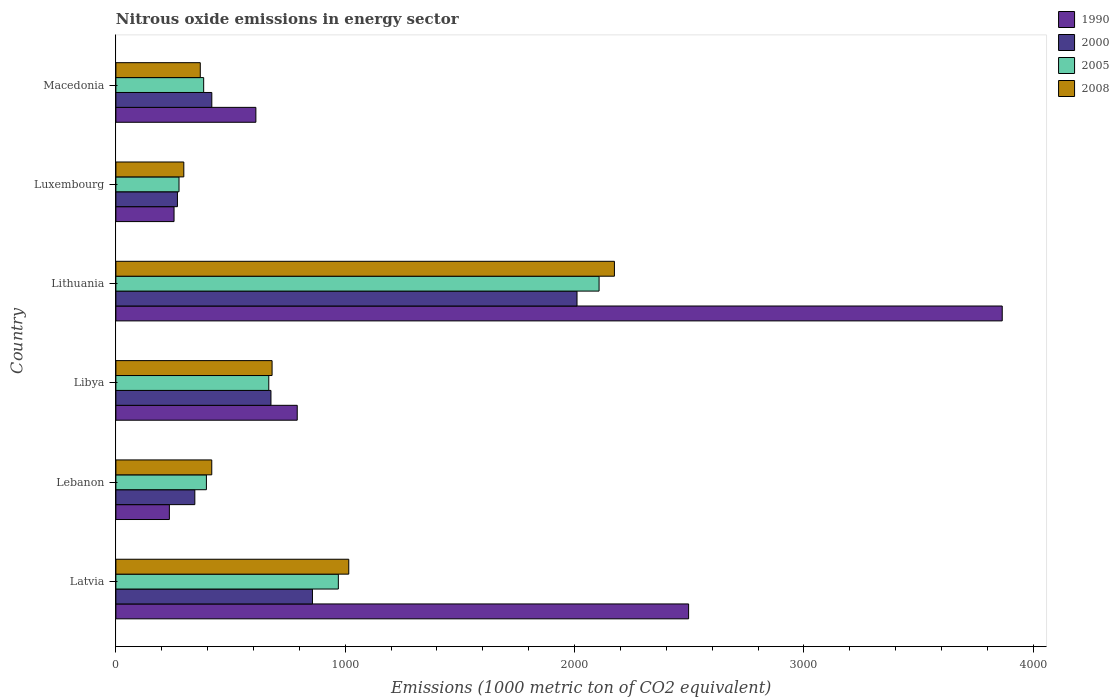How many different coloured bars are there?
Keep it short and to the point. 4. Are the number of bars on each tick of the Y-axis equal?
Ensure brevity in your answer.  Yes. How many bars are there on the 3rd tick from the bottom?
Your answer should be compact. 4. What is the label of the 1st group of bars from the top?
Make the answer very short. Macedonia. What is the amount of nitrous oxide emitted in 2005 in Libya?
Your response must be concise. 666.7. Across all countries, what is the maximum amount of nitrous oxide emitted in 2000?
Provide a succinct answer. 2010.8. Across all countries, what is the minimum amount of nitrous oxide emitted in 2008?
Your answer should be compact. 296.2. In which country was the amount of nitrous oxide emitted in 2008 maximum?
Your response must be concise. Lithuania. In which country was the amount of nitrous oxide emitted in 2005 minimum?
Give a very brief answer. Luxembourg. What is the total amount of nitrous oxide emitted in 1990 in the graph?
Give a very brief answer. 8250.4. What is the difference between the amount of nitrous oxide emitted in 2000 in Latvia and that in Luxembourg?
Give a very brief answer. 588.7. What is the difference between the amount of nitrous oxide emitted in 2000 in Libya and the amount of nitrous oxide emitted in 1990 in Lithuania?
Offer a very short reply. -3188.8. What is the average amount of nitrous oxide emitted in 2005 per country?
Offer a very short reply. 799.42. What is the difference between the amount of nitrous oxide emitted in 2005 and amount of nitrous oxide emitted in 2000 in Lithuania?
Make the answer very short. 96.2. In how many countries, is the amount of nitrous oxide emitted in 2008 greater than 1600 1000 metric ton?
Your answer should be compact. 1. What is the ratio of the amount of nitrous oxide emitted in 2008 in Latvia to that in Lithuania?
Make the answer very short. 0.47. Is the amount of nitrous oxide emitted in 1990 in Lebanon less than that in Lithuania?
Give a very brief answer. Yes. Is the difference between the amount of nitrous oxide emitted in 2005 in Lithuania and Luxembourg greater than the difference between the amount of nitrous oxide emitted in 2000 in Lithuania and Luxembourg?
Your answer should be compact. Yes. What is the difference between the highest and the second highest amount of nitrous oxide emitted in 1990?
Make the answer very short. 1367.6. What is the difference between the highest and the lowest amount of nitrous oxide emitted in 2008?
Make the answer very short. 1877.7. Is the sum of the amount of nitrous oxide emitted in 2008 in Latvia and Lebanon greater than the maximum amount of nitrous oxide emitted in 2005 across all countries?
Ensure brevity in your answer.  No. What does the 4th bar from the bottom in Lebanon represents?
Offer a very short reply. 2008. How many countries are there in the graph?
Provide a succinct answer. 6. What is the difference between two consecutive major ticks on the X-axis?
Offer a very short reply. 1000. Does the graph contain grids?
Provide a succinct answer. No. What is the title of the graph?
Ensure brevity in your answer.  Nitrous oxide emissions in energy sector. Does "1999" appear as one of the legend labels in the graph?
Ensure brevity in your answer.  No. What is the label or title of the X-axis?
Offer a very short reply. Emissions (1000 metric ton of CO2 equivalent). What is the label or title of the Y-axis?
Ensure brevity in your answer.  Country. What is the Emissions (1000 metric ton of CO2 equivalent) in 1990 in Latvia?
Provide a succinct answer. 2497.4. What is the Emissions (1000 metric ton of CO2 equivalent) in 2000 in Latvia?
Make the answer very short. 857.1. What is the Emissions (1000 metric ton of CO2 equivalent) in 2005 in Latvia?
Your answer should be very brief. 970. What is the Emissions (1000 metric ton of CO2 equivalent) of 2008 in Latvia?
Your answer should be very brief. 1015.5. What is the Emissions (1000 metric ton of CO2 equivalent) in 1990 in Lebanon?
Give a very brief answer. 233.2. What is the Emissions (1000 metric ton of CO2 equivalent) in 2000 in Lebanon?
Your answer should be compact. 344.2. What is the Emissions (1000 metric ton of CO2 equivalent) in 2005 in Lebanon?
Your answer should be compact. 394.7. What is the Emissions (1000 metric ton of CO2 equivalent) in 2008 in Lebanon?
Provide a short and direct response. 418.1. What is the Emissions (1000 metric ton of CO2 equivalent) of 1990 in Libya?
Offer a very short reply. 790.8. What is the Emissions (1000 metric ton of CO2 equivalent) of 2000 in Libya?
Offer a terse response. 676.2. What is the Emissions (1000 metric ton of CO2 equivalent) in 2005 in Libya?
Provide a succinct answer. 666.7. What is the Emissions (1000 metric ton of CO2 equivalent) in 2008 in Libya?
Provide a short and direct response. 681.1. What is the Emissions (1000 metric ton of CO2 equivalent) in 1990 in Lithuania?
Keep it short and to the point. 3865. What is the Emissions (1000 metric ton of CO2 equivalent) of 2000 in Lithuania?
Keep it short and to the point. 2010.8. What is the Emissions (1000 metric ton of CO2 equivalent) in 2005 in Lithuania?
Offer a very short reply. 2107. What is the Emissions (1000 metric ton of CO2 equivalent) of 2008 in Lithuania?
Offer a terse response. 2173.9. What is the Emissions (1000 metric ton of CO2 equivalent) of 1990 in Luxembourg?
Keep it short and to the point. 253.6. What is the Emissions (1000 metric ton of CO2 equivalent) of 2000 in Luxembourg?
Your answer should be very brief. 268.4. What is the Emissions (1000 metric ton of CO2 equivalent) in 2005 in Luxembourg?
Provide a short and direct response. 275.3. What is the Emissions (1000 metric ton of CO2 equivalent) in 2008 in Luxembourg?
Give a very brief answer. 296.2. What is the Emissions (1000 metric ton of CO2 equivalent) in 1990 in Macedonia?
Your answer should be very brief. 610.4. What is the Emissions (1000 metric ton of CO2 equivalent) of 2000 in Macedonia?
Your answer should be very brief. 418.3. What is the Emissions (1000 metric ton of CO2 equivalent) in 2005 in Macedonia?
Your answer should be very brief. 382.8. What is the Emissions (1000 metric ton of CO2 equivalent) of 2008 in Macedonia?
Make the answer very short. 368. Across all countries, what is the maximum Emissions (1000 metric ton of CO2 equivalent) in 1990?
Keep it short and to the point. 3865. Across all countries, what is the maximum Emissions (1000 metric ton of CO2 equivalent) in 2000?
Make the answer very short. 2010.8. Across all countries, what is the maximum Emissions (1000 metric ton of CO2 equivalent) in 2005?
Offer a terse response. 2107. Across all countries, what is the maximum Emissions (1000 metric ton of CO2 equivalent) in 2008?
Provide a short and direct response. 2173.9. Across all countries, what is the minimum Emissions (1000 metric ton of CO2 equivalent) in 1990?
Give a very brief answer. 233.2. Across all countries, what is the minimum Emissions (1000 metric ton of CO2 equivalent) in 2000?
Make the answer very short. 268.4. Across all countries, what is the minimum Emissions (1000 metric ton of CO2 equivalent) of 2005?
Your response must be concise. 275.3. Across all countries, what is the minimum Emissions (1000 metric ton of CO2 equivalent) in 2008?
Your answer should be compact. 296.2. What is the total Emissions (1000 metric ton of CO2 equivalent) in 1990 in the graph?
Provide a succinct answer. 8250.4. What is the total Emissions (1000 metric ton of CO2 equivalent) in 2000 in the graph?
Your answer should be very brief. 4575. What is the total Emissions (1000 metric ton of CO2 equivalent) of 2005 in the graph?
Your answer should be very brief. 4796.5. What is the total Emissions (1000 metric ton of CO2 equivalent) of 2008 in the graph?
Ensure brevity in your answer.  4952.8. What is the difference between the Emissions (1000 metric ton of CO2 equivalent) of 1990 in Latvia and that in Lebanon?
Your answer should be very brief. 2264.2. What is the difference between the Emissions (1000 metric ton of CO2 equivalent) in 2000 in Latvia and that in Lebanon?
Offer a terse response. 512.9. What is the difference between the Emissions (1000 metric ton of CO2 equivalent) of 2005 in Latvia and that in Lebanon?
Provide a short and direct response. 575.3. What is the difference between the Emissions (1000 metric ton of CO2 equivalent) in 2008 in Latvia and that in Lebanon?
Keep it short and to the point. 597.4. What is the difference between the Emissions (1000 metric ton of CO2 equivalent) of 1990 in Latvia and that in Libya?
Offer a very short reply. 1706.6. What is the difference between the Emissions (1000 metric ton of CO2 equivalent) in 2000 in Latvia and that in Libya?
Give a very brief answer. 180.9. What is the difference between the Emissions (1000 metric ton of CO2 equivalent) in 2005 in Latvia and that in Libya?
Your answer should be very brief. 303.3. What is the difference between the Emissions (1000 metric ton of CO2 equivalent) of 2008 in Latvia and that in Libya?
Offer a terse response. 334.4. What is the difference between the Emissions (1000 metric ton of CO2 equivalent) of 1990 in Latvia and that in Lithuania?
Your response must be concise. -1367.6. What is the difference between the Emissions (1000 metric ton of CO2 equivalent) in 2000 in Latvia and that in Lithuania?
Give a very brief answer. -1153.7. What is the difference between the Emissions (1000 metric ton of CO2 equivalent) in 2005 in Latvia and that in Lithuania?
Make the answer very short. -1137. What is the difference between the Emissions (1000 metric ton of CO2 equivalent) in 2008 in Latvia and that in Lithuania?
Offer a very short reply. -1158.4. What is the difference between the Emissions (1000 metric ton of CO2 equivalent) of 1990 in Latvia and that in Luxembourg?
Your answer should be compact. 2243.8. What is the difference between the Emissions (1000 metric ton of CO2 equivalent) of 2000 in Latvia and that in Luxembourg?
Keep it short and to the point. 588.7. What is the difference between the Emissions (1000 metric ton of CO2 equivalent) in 2005 in Latvia and that in Luxembourg?
Make the answer very short. 694.7. What is the difference between the Emissions (1000 metric ton of CO2 equivalent) of 2008 in Latvia and that in Luxembourg?
Offer a terse response. 719.3. What is the difference between the Emissions (1000 metric ton of CO2 equivalent) of 1990 in Latvia and that in Macedonia?
Provide a succinct answer. 1887. What is the difference between the Emissions (1000 metric ton of CO2 equivalent) of 2000 in Latvia and that in Macedonia?
Your response must be concise. 438.8. What is the difference between the Emissions (1000 metric ton of CO2 equivalent) of 2005 in Latvia and that in Macedonia?
Give a very brief answer. 587.2. What is the difference between the Emissions (1000 metric ton of CO2 equivalent) in 2008 in Latvia and that in Macedonia?
Ensure brevity in your answer.  647.5. What is the difference between the Emissions (1000 metric ton of CO2 equivalent) of 1990 in Lebanon and that in Libya?
Keep it short and to the point. -557.6. What is the difference between the Emissions (1000 metric ton of CO2 equivalent) in 2000 in Lebanon and that in Libya?
Ensure brevity in your answer.  -332. What is the difference between the Emissions (1000 metric ton of CO2 equivalent) in 2005 in Lebanon and that in Libya?
Make the answer very short. -272. What is the difference between the Emissions (1000 metric ton of CO2 equivalent) in 2008 in Lebanon and that in Libya?
Make the answer very short. -263. What is the difference between the Emissions (1000 metric ton of CO2 equivalent) of 1990 in Lebanon and that in Lithuania?
Provide a short and direct response. -3631.8. What is the difference between the Emissions (1000 metric ton of CO2 equivalent) of 2000 in Lebanon and that in Lithuania?
Keep it short and to the point. -1666.6. What is the difference between the Emissions (1000 metric ton of CO2 equivalent) in 2005 in Lebanon and that in Lithuania?
Offer a terse response. -1712.3. What is the difference between the Emissions (1000 metric ton of CO2 equivalent) in 2008 in Lebanon and that in Lithuania?
Ensure brevity in your answer.  -1755.8. What is the difference between the Emissions (1000 metric ton of CO2 equivalent) of 1990 in Lebanon and that in Luxembourg?
Make the answer very short. -20.4. What is the difference between the Emissions (1000 metric ton of CO2 equivalent) of 2000 in Lebanon and that in Luxembourg?
Keep it short and to the point. 75.8. What is the difference between the Emissions (1000 metric ton of CO2 equivalent) in 2005 in Lebanon and that in Luxembourg?
Provide a short and direct response. 119.4. What is the difference between the Emissions (1000 metric ton of CO2 equivalent) in 2008 in Lebanon and that in Luxembourg?
Your answer should be very brief. 121.9. What is the difference between the Emissions (1000 metric ton of CO2 equivalent) of 1990 in Lebanon and that in Macedonia?
Offer a terse response. -377.2. What is the difference between the Emissions (1000 metric ton of CO2 equivalent) of 2000 in Lebanon and that in Macedonia?
Your response must be concise. -74.1. What is the difference between the Emissions (1000 metric ton of CO2 equivalent) of 2008 in Lebanon and that in Macedonia?
Your response must be concise. 50.1. What is the difference between the Emissions (1000 metric ton of CO2 equivalent) in 1990 in Libya and that in Lithuania?
Your answer should be compact. -3074.2. What is the difference between the Emissions (1000 metric ton of CO2 equivalent) of 2000 in Libya and that in Lithuania?
Provide a succinct answer. -1334.6. What is the difference between the Emissions (1000 metric ton of CO2 equivalent) in 2005 in Libya and that in Lithuania?
Provide a short and direct response. -1440.3. What is the difference between the Emissions (1000 metric ton of CO2 equivalent) of 2008 in Libya and that in Lithuania?
Offer a very short reply. -1492.8. What is the difference between the Emissions (1000 metric ton of CO2 equivalent) of 1990 in Libya and that in Luxembourg?
Make the answer very short. 537.2. What is the difference between the Emissions (1000 metric ton of CO2 equivalent) in 2000 in Libya and that in Luxembourg?
Give a very brief answer. 407.8. What is the difference between the Emissions (1000 metric ton of CO2 equivalent) in 2005 in Libya and that in Luxembourg?
Offer a very short reply. 391.4. What is the difference between the Emissions (1000 metric ton of CO2 equivalent) in 2008 in Libya and that in Luxembourg?
Your answer should be very brief. 384.9. What is the difference between the Emissions (1000 metric ton of CO2 equivalent) of 1990 in Libya and that in Macedonia?
Offer a very short reply. 180.4. What is the difference between the Emissions (1000 metric ton of CO2 equivalent) of 2000 in Libya and that in Macedonia?
Provide a short and direct response. 257.9. What is the difference between the Emissions (1000 metric ton of CO2 equivalent) of 2005 in Libya and that in Macedonia?
Keep it short and to the point. 283.9. What is the difference between the Emissions (1000 metric ton of CO2 equivalent) in 2008 in Libya and that in Macedonia?
Provide a succinct answer. 313.1. What is the difference between the Emissions (1000 metric ton of CO2 equivalent) of 1990 in Lithuania and that in Luxembourg?
Give a very brief answer. 3611.4. What is the difference between the Emissions (1000 metric ton of CO2 equivalent) in 2000 in Lithuania and that in Luxembourg?
Offer a terse response. 1742.4. What is the difference between the Emissions (1000 metric ton of CO2 equivalent) of 2005 in Lithuania and that in Luxembourg?
Provide a short and direct response. 1831.7. What is the difference between the Emissions (1000 metric ton of CO2 equivalent) in 2008 in Lithuania and that in Luxembourg?
Keep it short and to the point. 1877.7. What is the difference between the Emissions (1000 metric ton of CO2 equivalent) of 1990 in Lithuania and that in Macedonia?
Provide a succinct answer. 3254.6. What is the difference between the Emissions (1000 metric ton of CO2 equivalent) in 2000 in Lithuania and that in Macedonia?
Offer a terse response. 1592.5. What is the difference between the Emissions (1000 metric ton of CO2 equivalent) in 2005 in Lithuania and that in Macedonia?
Provide a succinct answer. 1724.2. What is the difference between the Emissions (1000 metric ton of CO2 equivalent) of 2008 in Lithuania and that in Macedonia?
Make the answer very short. 1805.9. What is the difference between the Emissions (1000 metric ton of CO2 equivalent) in 1990 in Luxembourg and that in Macedonia?
Offer a very short reply. -356.8. What is the difference between the Emissions (1000 metric ton of CO2 equivalent) of 2000 in Luxembourg and that in Macedonia?
Offer a very short reply. -149.9. What is the difference between the Emissions (1000 metric ton of CO2 equivalent) of 2005 in Luxembourg and that in Macedonia?
Provide a succinct answer. -107.5. What is the difference between the Emissions (1000 metric ton of CO2 equivalent) in 2008 in Luxembourg and that in Macedonia?
Give a very brief answer. -71.8. What is the difference between the Emissions (1000 metric ton of CO2 equivalent) in 1990 in Latvia and the Emissions (1000 metric ton of CO2 equivalent) in 2000 in Lebanon?
Make the answer very short. 2153.2. What is the difference between the Emissions (1000 metric ton of CO2 equivalent) of 1990 in Latvia and the Emissions (1000 metric ton of CO2 equivalent) of 2005 in Lebanon?
Make the answer very short. 2102.7. What is the difference between the Emissions (1000 metric ton of CO2 equivalent) of 1990 in Latvia and the Emissions (1000 metric ton of CO2 equivalent) of 2008 in Lebanon?
Your response must be concise. 2079.3. What is the difference between the Emissions (1000 metric ton of CO2 equivalent) in 2000 in Latvia and the Emissions (1000 metric ton of CO2 equivalent) in 2005 in Lebanon?
Offer a very short reply. 462.4. What is the difference between the Emissions (1000 metric ton of CO2 equivalent) in 2000 in Latvia and the Emissions (1000 metric ton of CO2 equivalent) in 2008 in Lebanon?
Keep it short and to the point. 439. What is the difference between the Emissions (1000 metric ton of CO2 equivalent) of 2005 in Latvia and the Emissions (1000 metric ton of CO2 equivalent) of 2008 in Lebanon?
Provide a short and direct response. 551.9. What is the difference between the Emissions (1000 metric ton of CO2 equivalent) of 1990 in Latvia and the Emissions (1000 metric ton of CO2 equivalent) of 2000 in Libya?
Provide a short and direct response. 1821.2. What is the difference between the Emissions (1000 metric ton of CO2 equivalent) in 1990 in Latvia and the Emissions (1000 metric ton of CO2 equivalent) in 2005 in Libya?
Provide a succinct answer. 1830.7. What is the difference between the Emissions (1000 metric ton of CO2 equivalent) in 1990 in Latvia and the Emissions (1000 metric ton of CO2 equivalent) in 2008 in Libya?
Provide a short and direct response. 1816.3. What is the difference between the Emissions (1000 metric ton of CO2 equivalent) of 2000 in Latvia and the Emissions (1000 metric ton of CO2 equivalent) of 2005 in Libya?
Give a very brief answer. 190.4. What is the difference between the Emissions (1000 metric ton of CO2 equivalent) of 2000 in Latvia and the Emissions (1000 metric ton of CO2 equivalent) of 2008 in Libya?
Give a very brief answer. 176. What is the difference between the Emissions (1000 metric ton of CO2 equivalent) in 2005 in Latvia and the Emissions (1000 metric ton of CO2 equivalent) in 2008 in Libya?
Provide a succinct answer. 288.9. What is the difference between the Emissions (1000 metric ton of CO2 equivalent) of 1990 in Latvia and the Emissions (1000 metric ton of CO2 equivalent) of 2000 in Lithuania?
Ensure brevity in your answer.  486.6. What is the difference between the Emissions (1000 metric ton of CO2 equivalent) in 1990 in Latvia and the Emissions (1000 metric ton of CO2 equivalent) in 2005 in Lithuania?
Offer a very short reply. 390.4. What is the difference between the Emissions (1000 metric ton of CO2 equivalent) in 1990 in Latvia and the Emissions (1000 metric ton of CO2 equivalent) in 2008 in Lithuania?
Your answer should be very brief. 323.5. What is the difference between the Emissions (1000 metric ton of CO2 equivalent) of 2000 in Latvia and the Emissions (1000 metric ton of CO2 equivalent) of 2005 in Lithuania?
Make the answer very short. -1249.9. What is the difference between the Emissions (1000 metric ton of CO2 equivalent) in 2000 in Latvia and the Emissions (1000 metric ton of CO2 equivalent) in 2008 in Lithuania?
Give a very brief answer. -1316.8. What is the difference between the Emissions (1000 metric ton of CO2 equivalent) in 2005 in Latvia and the Emissions (1000 metric ton of CO2 equivalent) in 2008 in Lithuania?
Offer a terse response. -1203.9. What is the difference between the Emissions (1000 metric ton of CO2 equivalent) in 1990 in Latvia and the Emissions (1000 metric ton of CO2 equivalent) in 2000 in Luxembourg?
Your answer should be compact. 2229. What is the difference between the Emissions (1000 metric ton of CO2 equivalent) in 1990 in Latvia and the Emissions (1000 metric ton of CO2 equivalent) in 2005 in Luxembourg?
Offer a very short reply. 2222.1. What is the difference between the Emissions (1000 metric ton of CO2 equivalent) in 1990 in Latvia and the Emissions (1000 metric ton of CO2 equivalent) in 2008 in Luxembourg?
Offer a terse response. 2201.2. What is the difference between the Emissions (1000 metric ton of CO2 equivalent) of 2000 in Latvia and the Emissions (1000 metric ton of CO2 equivalent) of 2005 in Luxembourg?
Offer a terse response. 581.8. What is the difference between the Emissions (1000 metric ton of CO2 equivalent) in 2000 in Latvia and the Emissions (1000 metric ton of CO2 equivalent) in 2008 in Luxembourg?
Provide a succinct answer. 560.9. What is the difference between the Emissions (1000 metric ton of CO2 equivalent) of 2005 in Latvia and the Emissions (1000 metric ton of CO2 equivalent) of 2008 in Luxembourg?
Make the answer very short. 673.8. What is the difference between the Emissions (1000 metric ton of CO2 equivalent) of 1990 in Latvia and the Emissions (1000 metric ton of CO2 equivalent) of 2000 in Macedonia?
Provide a succinct answer. 2079.1. What is the difference between the Emissions (1000 metric ton of CO2 equivalent) in 1990 in Latvia and the Emissions (1000 metric ton of CO2 equivalent) in 2005 in Macedonia?
Give a very brief answer. 2114.6. What is the difference between the Emissions (1000 metric ton of CO2 equivalent) in 1990 in Latvia and the Emissions (1000 metric ton of CO2 equivalent) in 2008 in Macedonia?
Offer a very short reply. 2129.4. What is the difference between the Emissions (1000 metric ton of CO2 equivalent) of 2000 in Latvia and the Emissions (1000 metric ton of CO2 equivalent) of 2005 in Macedonia?
Your answer should be compact. 474.3. What is the difference between the Emissions (1000 metric ton of CO2 equivalent) of 2000 in Latvia and the Emissions (1000 metric ton of CO2 equivalent) of 2008 in Macedonia?
Your answer should be compact. 489.1. What is the difference between the Emissions (1000 metric ton of CO2 equivalent) in 2005 in Latvia and the Emissions (1000 metric ton of CO2 equivalent) in 2008 in Macedonia?
Offer a terse response. 602. What is the difference between the Emissions (1000 metric ton of CO2 equivalent) in 1990 in Lebanon and the Emissions (1000 metric ton of CO2 equivalent) in 2000 in Libya?
Your response must be concise. -443. What is the difference between the Emissions (1000 metric ton of CO2 equivalent) in 1990 in Lebanon and the Emissions (1000 metric ton of CO2 equivalent) in 2005 in Libya?
Make the answer very short. -433.5. What is the difference between the Emissions (1000 metric ton of CO2 equivalent) of 1990 in Lebanon and the Emissions (1000 metric ton of CO2 equivalent) of 2008 in Libya?
Provide a succinct answer. -447.9. What is the difference between the Emissions (1000 metric ton of CO2 equivalent) of 2000 in Lebanon and the Emissions (1000 metric ton of CO2 equivalent) of 2005 in Libya?
Your answer should be very brief. -322.5. What is the difference between the Emissions (1000 metric ton of CO2 equivalent) of 2000 in Lebanon and the Emissions (1000 metric ton of CO2 equivalent) of 2008 in Libya?
Ensure brevity in your answer.  -336.9. What is the difference between the Emissions (1000 metric ton of CO2 equivalent) in 2005 in Lebanon and the Emissions (1000 metric ton of CO2 equivalent) in 2008 in Libya?
Your answer should be very brief. -286.4. What is the difference between the Emissions (1000 metric ton of CO2 equivalent) of 1990 in Lebanon and the Emissions (1000 metric ton of CO2 equivalent) of 2000 in Lithuania?
Offer a terse response. -1777.6. What is the difference between the Emissions (1000 metric ton of CO2 equivalent) of 1990 in Lebanon and the Emissions (1000 metric ton of CO2 equivalent) of 2005 in Lithuania?
Keep it short and to the point. -1873.8. What is the difference between the Emissions (1000 metric ton of CO2 equivalent) of 1990 in Lebanon and the Emissions (1000 metric ton of CO2 equivalent) of 2008 in Lithuania?
Keep it short and to the point. -1940.7. What is the difference between the Emissions (1000 metric ton of CO2 equivalent) in 2000 in Lebanon and the Emissions (1000 metric ton of CO2 equivalent) in 2005 in Lithuania?
Make the answer very short. -1762.8. What is the difference between the Emissions (1000 metric ton of CO2 equivalent) of 2000 in Lebanon and the Emissions (1000 metric ton of CO2 equivalent) of 2008 in Lithuania?
Your response must be concise. -1829.7. What is the difference between the Emissions (1000 metric ton of CO2 equivalent) in 2005 in Lebanon and the Emissions (1000 metric ton of CO2 equivalent) in 2008 in Lithuania?
Give a very brief answer. -1779.2. What is the difference between the Emissions (1000 metric ton of CO2 equivalent) in 1990 in Lebanon and the Emissions (1000 metric ton of CO2 equivalent) in 2000 in Luxembourg?
Your answer should be compact. -35.2. What is the difference between the Emissions (1000 metric ton of CO2 equivalent) in 1990 in Lebanon and the Emissions (1000 metric ton of CO2 equivalent) in 2005 in Luxembourg?
Give a very brief answer. -42.1. What is the difference between the Emissions (1000 metric ton of CO2 equivalent) in 1990 in Lebanon and the Emissions (1000 metric ton of CO2 equivalent) in 2008 in Luxembourg?
Ensure brevity in your answer.  -63. What is the difference between the Emissions (1000 metric ton of CO2 equivalent) of 2000 in Lebanon and the Emissions (1000 metric ton of CO2 equivalent) of 2005 in Luxembourg?
Provide a short and direct response. 68.9. What is the difference between the Emissions (1000 metric ton of CO2 equivalent) in 2005 in Lebanon and the Emissions (1000 metric ton of CO2 equivalent) in 2008 in Luxembourg?
Keep it short and to the point. 98.5. What is the difference between the Emissions (1000 metric ton of CO2 equivalent) in 1990 in Lebanon and the Emissions (1000 metric ton of CO2 equivalent) in 2000 in Macedonia?
Make the answer very short. -185.1. What is the difference between the Emissions (1000 metric ton of CO2 equivalent) in 1990 in Lebanon and the Emissions (1000 metric ton of CO2 equivalent) in 2005 in Macedonia?
Provide a succinct answer. -149.6. What is the difference between the Emissions (1000 metric ton of CO2 equivalent) of 1990 in Lebanon and the Emissions (1000 metric ton of CO2 equivalent) of 2008 in Macedonia?
Provide a short and direct response. -134.8. What is the difference between the Emissions (1000 metric ton of CO2 equivalent) of 2000 in Lebanon and the Emissions (1000 metric ton of CO2 equivalent) of 2005 in Macedonia?
Give a very brief answer. -38.6. What is the difference between the Emissions (1000 metric ton of CO2 equivalent) in 2000 in Lebanon and the Emissions (1000 metric ton of CO2 equivalent) in 2008 in Macedonia?
Give a very brief answer. -23.8. What is the difference between the Emissions (1000 metric ton of CO2 equivalent) in 2005 in Lebanon and the Emissions (1000 metric ton of CO2 equivalent) in 2008 in Macedonia?
Keep it short and to the point. 26.7. What is the difference between the Emissions (1000 metric ton of CO2 equivalent) of 1990 in Libya and the Emissions (1000 metric ton of CO2 equivalent) of 2000 in Lithuania?
Give a very brief answer. -1220. What is the difference between the Emissions (1000 metric ton of CO2 equivalent) in 1990 in Libya and the Emissions (1000 metric ton of CO2 equivalent) in 2005 in Lithuania?
Offer a very short reply. -1316.2. What is the difference between the Emissions (1000 metric ton of CO2 equivalent) of 1990 in Libya and the Emissions (1000 metric ton of CO2 equivalent) of 2008 in Lithuania?
Offer a terse response. -1383.1. What is the difference between the Emissions (1000 metric ton of CO2 equivalent) in 2000 in Libya and the Emissions (1000 metric ton of CO2 equivalent) in 2005 in Lithuania?
Offer a terse response. -1430.8. What is the difference between the Emissions (1000 metric ton of CO2 equivalent) of 2000 in Libya and the Emissions (1000 metric ton of CO2 equivalent) of 2008 in Lithuania?
Keep it short and to the point. -1497.7. What is the difference between the Emissions (1000 metric ton of CO2 equivalent) of 2005 in Libya and the Emissions (1000 metric ton of CO2 equivalent) of 2008 in Lithuania?
Your answer should be compact. -1507.2. What is the difference between the Emissions (1000 metric ton of CO2 equivalent) of 1990 in Libya and the Emissions (1000 metric ton of CO2 equivalent) of 2000 in Luxembourg?
Your answer should be very brief. 522.4. What is the difference between the Emissions (1000 metric ton of CO2 equivalent) in 1990 in Libya and the Emissions (1000 metric ton of CO2 equivalent) in 2005 in Luxembourg?
Make the answer very short. 515.5. What is the difference between the Emissions (1000 metric ton of CO2 equivalent) of 1990 in Libya and the Emissions (1000 metric ton of CO2 equivalent) of 2008 in Luxembourg?
Keep it short and to the point. 494.6. What is the difference between the Emissions (1000 metric ton of CO2 equivalent) in 2000 in Libya and the Emissions (1000 metric ton of CO2 equivalent) in 2005 in Luxembourg?
Ensure brevity in your answer.  400.9. What is the difference between the Emissions (1000 metric ton of CO2 equivalent) in 2000 in Libya and the Emissions (1000 metric ton of CO2 equivalent) in 2008 in Luxembourg?
Offer a terse response. 380. What is the difference between the Emissions (1000 metric ton of CO2 equivalent) in 2005 in Libya and the Emissions (1000 metric ton of CO2 equivalent) in 2008 in Luxembourg?
Offer a terse response. 370.5. What is the difference between the Emissions (1000 metric ton of CO2 equivalent) of 1990 in Libya and the Emissions (1000 metric ton of CO2 equivalent) of 2000 in Macedonia?
Give a very brief answer. 372.5. What is the difference between the Emissions (1000 metric ton of CO2 equivalent) of 1990 in Libya and the Emissions (1000 metric ton of CO2 equivalent) of 2005 in Macedonia?
Your answer should be compact. 408. What is the difference between the Emissions (1000 metric ton of CO2 equivalent) of 1990 in Libya and the Emissions (1000 metric ton of CO2 equivalent) of 2008 in Macedonia?
Provide a succinct answer. 422.8. What is the difference between the Emissions (1000 metric ton of CO2 equivalent) in 2000 in Libya and the Emissions (1000 metric ton of CO2 equivalent) in 2005 in Macedonia?
Offer a terse response. 293.4. What is the difference between the Emissions (1000 metric ton of CO2 equivalent) in 2000 in Libya and the Emissions (1000 metric ton of CO2 equivalent) in 2008 in Macedonia?
Offer a terse response. 308.2. What is the difference between the Emissions (1000 metric ton of CO2 equivalent) in 2005 in Libya and the Emissions (1000 metric ton of CO2 equivalent) in 2008 in Macedonia?
Provide a succinct answer. 298.7. What is the difference between the Emissions (1000 metric ton of CO2 equivalent) in 1990 in Lithuania and the Emissions (1000 metric ton of CO2 equivalent) in 2000 in Luxembourg?
Provide a succinct answer. 3596.6. What is the difference between the Emissions (1000 metric ton of CO2 equivalent) of 1990 in Lithuania and the Emissions (1000 metric ton of CO2 equivalent) of 2005 in Luxembourg?
Your answer should be very brief. 3589.7. What is the difference between the Emissions (1000 metric ton of CO2 equivalent) in 1990 in Lithuania and the Emissions (1000 metric ton of CO2 equivalent) in 2008 in Luxembourg?
Ensure brevity in your answer.  3568.8. What is the difference between the Emissions (1000 metric ton of CO2 equivalent) in 2000 in Lithuania and the Emissions (1000 metric ton of CO2 equivalent) in 2005 in Luxembourg?
Your answer should be very brief. 1735.5. What is the difference between the Emissions (1000 metric ton of CO2 equivalent) of 2000 in Lithuania and the Emissions (1000 metric ton of CO2 equivalent) of 2008 in Luxembourg?
Your answer should be very brief. 1714.6. What is the difference between the Emissions (1000 metric ton of CO2 equivalent) in 2005 in Lithuania and the Emissions (1000 metric ton of CO2 equivalent) in 2008 in Luxembourg?
Provide a short and direct response. 1810.8. What is the difference between the Emissions (1000 metric ton of CO2 equivalent) of 1990 in Lithuania and the Emissions (1000 metric ton of CO2 equivalent) of 2000 in Macedonia?
Provide a short and direct response. 3446.7. What is the difference between the Emissions (1000 metric ton of CO2 equivalent) in 1990 in Lithuania and the Emissions (1000 metric ton of CO2 equivalent) in 2005 in Macedonia?
Offer a very short reply. 3482.2. What is the difference between the Emissions (1000 metric ton of CO2 equivalent) in 1990 in Lithuania and the Emissions (1000 metric ton of CO2 equivalent) in 2008 in Macedonia?
Keep it short and to the point. 3497. What is the difference between the Emissions (1000 metric ton of CO2 equivalent) of 2000 in Lithuania and the Emissions (1000 metric ton of CO2 equivalent) of 2005 in Macedonia?
Your answer should be very brief. 1628. What is the difference between the Emissions (1000 metric ton of CO2 equivalent) of 2000 in Lithuania and the Emissions (1000 metric ton of CO2 equivalent) of 2008 in Macedonia?
Offer a very short reply. 1642.8. What is the difference between the Emissions (1000 metric ton of CO2 equivalent) of 2005 in Lithuania and the Emissions (1000 metric ton of CO2 equivalent) of 2008 in Macedonia?
Provide a short and direct response. 1739. What is the difference between the Emissions (1000 metric ton of CO2 equivalent) in 1990 in Luxembourg and the Emissions (1000 metric ton of CO2 equivalent) in 2000 in Macedonia?
Offer a very short reply. -164.7. What is the difference between the Emissions (1000 metric ton of CO2 equivalent) in 1990 in Luxembourg and the Emissions (1000 metric ton of CO2 equivalent) in 2005 in Macedonia?
Offer a very short reply. -129.2. What is the difference between the Emissions (1000 metric ton of CO2 equivalent) in 1990 in Luxembourg and the Emissions (1000 metric ton of CO2 equivalent) in 2008 in Macedonia?
Your answer should be very brief. -114.4. What is the difference between the Emissions (1000 metric ton of CO2 equivalent) in 2000 in Luxembourg and the Emissions (1000 metric ton of CO2 equivalent) in 2005 in Macedonia?
Keep it short and to the point. -114.4. What is the difference between the Emissions (1000 metric ton of CO2 equivalent) in 2000 in Luxembourg and the Emissions (1000 metric ton of CO2 equivalent) in 2008 in Macedonia?
Your answer should be very brief. -99.6. What is the difference between the Emissions (1000 metric ton of CO2 equivalent) of 2005 in Luxembourg and the Emissions (1000 metric ton of CO2 equivalent) of 2008 in Macedonia?
Keep it short and to the point. -92.7. What is the average Emissions (1000 metric ton of CO2 equivalent) in 1990 per country?
Your answer should be compact. 1375.07. What is the average Emissions (1000 metric ton of CO2 equivalent) of 2000 per country?
Your answer should be compact. 762.5. What is the average Emissions (1000 metric ton of CO2 equivalent) in 2005 per country?
Make the answer very short. 799.42. What is the average Emissions (1000 metric ton of CO2 equivalent) of 2008 per country?
Make the answer very short. 825.47. What is the difference between the Emissions (1000 metric ton of CO2 equivalent) of 1990 and Emissions (1000 metric ton of CO2 equivalent) of 2000 in Latvia?
Ensure brevity in your answer.  1640.3. What is the difference between the Emissions (1000 metric ton of CO2 equivalent) of 1990 and Emissions (1000 metric ton of CO2 equivalent) of 2005 in Latvia?
Offer a terse response. 1527.4. What is the difference between the Emissions (1000 metric ton of CO2 equivalent) of 1990 and Emissions (1000 metric ton of CO2 equivalent) of 2008 in Latvia?
Offer a terse response. 1481.9. What is the difference between the Emissions (1000 metric ton of CO2 equivalent) of 2000 and Emissions (1000 metric ton of CO2 equivalent) of 2005 in Latvia?
Your response must be concise. -112.9. What is the difference between the Emissions (1000 metric ton of CO2 equivalent) in 2000 and Emissions (1000 metric ton of CO2 equivalent) in 2008 in Latvia?
Ensure brevity in your answer.  -158.4. What is the difference between the Emissions (1000 metric ton of CO2 equivalent) in 2005 and Emissions (1000 metric ton of CO2 equivalent) in 2008 in Latvia?
Provide a short and direct response. -45.5. What is the difference between the Emissions (1000 metric ton of CO2 equivalent) of 1990 and Emissions (1000 metric ton of CO2 equivalent) of 2000 in Lebanon?
Ensure brevity in your answer.  -111. What is the difference between the Emissions (1000 metric ton of CO2 equivalent) of 1990 and Emissions (1000 metric ton of CO2 equivalent) of 2005 in Lebanon?
Your answer should be compact. -161.5. What is the difference between the Emissions (1000 metric ton of CO2 equivalent) of 1990 and Emissions (1000 metric ton of CO2 equivalent) of 2008 in Lebanon?
Your answer should be very brief. -184.9. What is the difference between the Emissions (1000 metric ton of CO2 equivalent) in 2000 and Emissions (1000 metric ton of CO2 equivalent) in 2005 in Lebanon?
Your answer should be very brief. -50.5. What is the difference between the Emissions (1000 metric ton of CO2 equivalent) in 2000 and Emissions (1000 metric ton of CO2 equivalent) in 2008 in Lebanon?
Offer a very short reply. -73.9. What is the difference between the Emissions (1000 metric ton of CO2 equivalent) of 2005 and Emissions (1000 metric ton of CO2 equivalent) of 2008 in Lebanon?
Your answer should be compact. -23.4. What is the difference between the Emissions (1000 metric ton of CO2 equivalent) in 1990 and Emissions (1000 metric ton of CO2 equivalent) in 2000 in Libya?
Provide a succinct answer. 114.6. What is the difference between the Emissions (1000 metric ton of CO2 equivalent) of 1990 and Emissions (1000 metric ton of CO2 equivalent) of 2005 in Libya?
Make the answer very short. 124.1. What is the difference between the Emissions (1000 metric ton of CO2 equivalent) of 1990 and Emissions (1000 metric ton of CO2 equivalent) of 2008 in Libya?
Your response must be concise. 109.7. What is the difference between the Emissions (1000 metric ton of CO2 equivalent) of 2000 and Emissions (1000 metric ton of CO2 equivalent) of 2005 in Libya?
Ensure brevity in your answer.  9.5. What is the difference between the Emissions (1000 metric ton of CO2 equivalent) of 2005 and Emissions (1000 metric ton of CO2 equivalent) of 2008 in Libya?
Your response must be concise. -14.4. What is the difference between the Emissions (1000 metric ton of CO2 equivalent) in 1990 and Emissions (1000 metric ton of CO2 equivalent) in 2000 in Lithuania?
Keep it short and to the point. 1854.2. What is the difference between the Emissions (1000 metric ton of CO2 equivalent) in 1990 and Emissions (1000 metric ton of CO2 equivalent) in 2005 in Lithuania?
Give a very brief answer. 1758. What is the difference between the Emissions (1000 metric ton of CO2 equivalent) in 1990 and Emissions (1000 metric ton of CO2 equivalent) in 2008 in Lithuania?
Your answer should be very brief. 1691.1. What is the difference between the Emissions (1000 metric ton of CO2 equivalent) of 2000 and Emissions (1000 metric ton of CO2 equivalent) of 2005 in Lithuania?
Offer a terse response. -96.2. What is the difference between the Emissions (1000 metric ton of CO2 equivalent) of 2000 and Emissions (1000 metric ton of CO2 equivalent) of 2008 in Lithuania?
Offer a very short reply. -163.1. What is the difference between the Emissions (1000 metric ton of CO2 equivalent) in 2005 and Emissions (1000 metric ton of CO2 equivalent) in 2008 in Lithuania?
Your answer should be compact. -66.9. What is the difference between the Emissions (1000 metric ton of CO2 equivalent) of 1990 and Emissions (1000 metric ton of CO2 equivalent) of 2000 in Luxembourg?
Ensure brevity in your answer.  -14.8. What is the difference between the Emissions (1000 metric ton of CO2 equivalent) in 1990 and Emissions (1000 metric ton of CO2 equivalent) in 2005 in Luxembourg?
Your answer should be very brief. -21.7. What is the difference between the Emissions (1000 metric ton of CO2 equivalent) in 1990 and Emissions (1000 metric ton of CO2 equivalent) in 2008 in Luxembourg?
Your response must be concise. -42.6. What is the difference between the Emissions (1000 metric ton of CO2 equivalent) in 2000 and Emissions (1000 metric ton of CO2 equivalent) in 2008 in Luxembourg?
Your answer should be very brief. -27.8. What is the difference between the Emissions (1000 metric ton of CO2 equivalent) in 2005 and Emissions (1000 metric ton of CO2 equivalent) in 2008 in Luxembourg?
Ensure brevity in your answer.  -20.9. What is the difference between the Emissions (1000 metric ton of CO2 equivalent) of 1990 and Emissions (1000 metric ton of CO2 equivalent) of 2000 in Macedonia?
Give a very brief answer. 192.1. What is the difference between the Emissions (1000 metric ton of CO2 equivalent) in 1990 and Emissions (1000 metric ton of CO2 equivalent) in 2005 in Macedonia?
Ensure brevity in your answer.  227.6. What is the difference between the Emissions (1000 metric ton of CO2 equivalent) in 1990 and Emissions (1000 metric ton of CO2 equivalent) in 2008 in Macedonia?
Ensure brevity in your answer.  242.4. What is the difference between the Emissions (1000 metric ton of CO2 equivalent) of 2000 and Emissions (1000 metric ton of CO2 equivalent) of 2005 in Macedonia?
Ensure brevity in your answer.  35.5. What is the difference between the Emissions (1000 metric ton of CO2 equivalent) of 2000 and Emissions (1000 metric ton of CO2 equivalent) of 2008 in Macedonia?
Provide a succinct answer. 50.3. What is the difference between the Emissions (1000 metric ton of CO2 equivalent) of 2005 and Emissions (1000 metric ton of CO2 equivalent) of 2008 in Macedonia?
Make the answer very short. 14.8. What is the ratio of the Emissions (1000 metric ton of CO2 equivalent) in 1990 in Latvia to that in Lebanon?
Keep it short and to the point. 10.71. What is the ratio of the Emissions (1000 metric ton of CO2 equivalent) in 2000 in Latvia to that in Lebanon?
Provide a succinct answer. 2.49. What is the ratio of the Emissions (1000 metric ton of CO2 equivalent) in 2005 in Latvia to that in Lebanon?
Offer a very short reply. 2.46. What is the ratio of the Emissions (1000 metric ton of CO2 equivalent) of 2008 in Latvia to that in Lebanon?
Keep it short and to the point. 2.43. What is the ratio of the Emissions (1000 metric ton of CO2 equivalent) of 1990 in Latvia to that in Libya?
Ensure brevity in your answer.  3.16. What is the ratio of the Emissions (1000 metric ton of CO2 equivalent) of 2000 in Latvia to that in Libya?
Provide a short and direct response. 1.27. What is the ratio of the Emissions (1000 metric ton of CO2 equivalent) in 2005 in Latvia to that in Libya?
Your answer should be compact. 1.45. What is the ratio of the Emissions (1000 metric ton of CO2 equivalent) in 2008 in Latvia to that in Libya?
Your response must be concise. 1.49. What is the ratio of the Emissions (1000 metric ton of CO2 equivalent) of 1990 in Latvia to that in Lithuania?
Make the answer very short. 0.65. What is the ratio of the Emissions (1000 metric ton of CO2 equivalent) in 2000 in Latvia to that in Lithuania?
Provide a short and direct response. 0.43. What is the ratio of the Emissions (1000 metric ton of CO2 equivalent) in 2005 in Latvia to that in Lithuania?
Keep it short and to the point. 0.46. What is the ratio of the Emissions (1000 metric ton of CO2 equivalent) in 2008 in Latvia to that in Lithuania?
Your answer should be very brief. 0.47. What is the ratio of the Emissions (1000 metric ton of CO2 equivalent) in 1990 in Latvia to that in Luxembourg?
Provide a succinct answer. 9.85. What is the ratio of the Emissions (1000 metric ton of CO2 equivalent) of 2000 in Latvia to that in Luxembourg?
Your answer should be compact. 3.19. What is the ratio of the Emissions (1000 metric ton of CO2 equivalent) in 2005 in Latvia to that in Luxembourg?
Your answer should be compact. 3.52. What is the ratio of the Emissions (1000 metric ton of CO2 equivalent) of 2008 in Latvia to that in Luxembourg?
Keep it short and to the point. 3.43. What is the ratio of the Emissions (1000 metric ton of CO2 equivalent) in 1990 in Latvia to that in Macedonia?
Your answer should be very brief. 4.09. What is the ratio of the Emissions (1000 metric ton of CO2 equivalent) of 2000 in Latvia to that in Macedonia?
Give a very brief answer. 2.05. What is the ratio of the Emissions (1000 metric ton of CO2 equivalent) of 2005 in Latvia to that in Macedonia?
Your answer should be very brief. 2.53. What is the ratio of the Emissions (1000 metric ton of CO2 equivalent) in 2008 in Latvia to that in Macedonia?
Your answer should be very brief. 2.76. What is the ratio of the Emissions (1000 metric ton of CO2 equivalent) in 1990 in Lebanon to that in Libya?
Offer a terse response. 0.29. What is the ratio of the Emissions (1000 metric ton of CO2 equivalent) of 2000 in Lebanon to that in Libya?
Give a very brief answer. 0.51. What is the ratio of the Emissions (1000 metric ton of CO2 equivalent) in 2005 in Lebanon to that in Libya?
Provide a succinct answer. 0.59. What is the ratio of the Emissions (1000 metric ton of CO2 equivalent) in 2008 in Lebanon to that in Libya?
Provide a succinct answer. 0.61. What is the ratio of the Emissions (1000 metric ton of CO2 equivalent) of 1990 in Lebanon to that in Lithuania?
Make the answer very short. 0.06. What is the ratio of the Emissions (1000 metric ton of CO2 equivalent) in 2000 in Lebanon to that in Lithuania?
Your answer should be compact. 0.17. What is the ratio of the Emissions (1000 metric ton of CO2 equivalent) of 2005 in Lebanon to that in Lithuania?
Offer a terse response. 0.19. What is the ratio of the Emissions (1000 metric ton of CO2 equivalent) of 2008 in Lebanon to that in Lithuania?
Your answer should be compact. 0.19. What is the ratio of the Emissions (1000 metric ton of CO2 equivalent) in 1990 in Lebanon to that in Luxembourg?
Keep it short and to the point. 0.92. What is the ratio of the Emissions (1000 metric ton of CO2 equivalent) in 2000 in Lebanon to that in Luxembourg?
Provide a short and direct response. 1.28. What is the ratio of the Emissions (1000 metric ton of CO2 equivalent) of 2005 in Lebanon to that in Luxembourg?
Your response must be concise. 1.43. What is the ratio of the Emissions (1000 metric ton of CO2 equivalent) in 2008 in Lebanon to that in Luxembourg?
Provide a short and direct response. 1.41. What is the ratio of the Emissions (1000 metric ton of CO2 equivalent) of 1990 in Lebanon to that in Macedonia?
Keep it short and to the point. 0.38. What is the ratio of the Emissions (1000 metric ton of CO2 equivalent) in 2000 in Lebanon to that in Macedonia?
Ensure brevity in your answer.  0.82. What is the ratio of the Emissions (1000 metric ton of CO2 equivalent) in 2005 in Lebanon to that in Macedonia?
Offer a very short reply. 1.03. What is the ratio of the Emissions (1000 metric ton of CO2 equivalent) in 2008 in Lebanon to that in Macedonia?
Give a very brief answer. 1.14. What is the ratio of the Emissions (1000 metric ton of CO2 equivalent) in 1990 in Libya to that in Lithuania?
Ensure brevity in your answer.  0.2. What is the ratio of the Emissions (1000 metric ton of CO2 equivalent) in 2000 in Libya to that in Lithuania?
Keep it short and to the point. 0.34. What is the ratio of the Emissions (1000 metric ton of CO2 equivalent) in 2005 in Libya to that in Lithuania?
Your answer should be very brief. 0.32. What is the ratio of the Emissions (1000 metric ton of CO2 equivalent) of 2008 in Libya to that in Lithuania?
Give a very brief answer. 0.31. What is the ratio of the Emissions (1000 metric ton of CO2 equivalent) of 1990 in Libya to that in Luxembourg?
Your response must be concise. 3.12. What is the ratio of the Emissions (1000 metric ton of CO2 equivalent) of 2000 in Libya to that in Luxembourg?
Offer a terse response. 2.52. What is the ratio of the Emissions (1000 metric ton of CO2 equivalent) in 2005 in Libya to that in Luxembourg?
Offer a very short reply. 2.42. What is the ratio of the Emissions (1000 metric ton of CO2 equivalent) of 2008 in Libya to that in Luxembourg?
Make the answer very short. 2.3. What is the ratio of the Emissions (1000 metric ton of CO2 equivalent) in 1990 in Libya to that in Macedonia?
Your answer should be compact. 1.3. What is the ratio of the Emissions (1000 metric ton of CO2 equivalent) in 2000 in Libya to that in Macedonia?
Ensure brevity in your answer.  1.62. What is the ratio of the Emissions (1000 metric ton of CO2 equivalent) of 2005 in Libya to that in Macedonia?
Provide a succinct answer. 1.74. What is the ratio of the Emissions (1000 metric ton of CO2 equivalent) of 2008 in Libya to that in Macedonia?
Give a very brief answer. 1.85. What is the ratio of the Emissions (1000 metric ton of CO2 equivalent) in 1990 in Lithuania to that in Luxembourg?
Offer a terse response. 15.24. What is the ratio of the Emissions (1000 metric ton of CO2 equivalent) of 2000 in Lithuania to that in Luxembourg?
Your answer should be very brief. 7.49. What is the ratio of the Emissions (1000 metric ton of CO2 equivalent) of 2005 in Lithuania to that in Luxembourg?
Make the answer very short. 7.65. What is the ratio of the Emissions (1000 metric ton of CO2 equivalent) of 2008 in Lithuania to that in Luxembourg?
Offer a very short reply. 7.34. What is the ratio of the Emissions (1000 metric ton of CO2 equivalent) of 1990 in Lithuania to that in Macedonia?
Offer a very short reply. 6.33. What is the ratio of the Emissions (1000 metric ton of CO2 equivalent) in 2000 in Lithuania to that in Macedonia?
Offer a terse response. 4.81. What is the ratio of the Emissions (1000 metric ton of CO2 equivalent) of 2005 in Lithuania to that in Macedonia?
Offer a terse response. 5.5. What is the ratio of the Emissions (1000 metric ton of CO2 equivalent) of 2008 in Lithuania to that in Macedonia?
Your response must be concise. 5.91. What is the ratio of the Emissions (1000 metric ton of CO2 equivalent) of 1990 in Luxembourg to that in Macedonia?
Make the answer very short. 0.42. What is the ratio of the Emissions (1000 metric ton of CO2 equivalent) in 2000 in Luxembourg to that in Macedonia?
Keep it short and to the point. 0.64. What is the ratio of the Emissions (1000 metric ton of CO2 equivalent) in 2005 in Luxembourg to that in Macedonia?
Offer a very short reply. 0.72. What is the ratio of the Emissions (1000 metric ton of CO2 equivalent) in 2008 in Luxembourg to that in Macedonia?
Your response must be concise. 0.8. What is the difference between the highest and the second highest Emissions (1000 metric ton of CO2 equivalent) of 1990?
Provide a short and direct response. 1367.6. What is the difference between the highest and the second highest Emissions (1000 metric ton of CO2 equivalent) of 2000?
Your response must be concise. 1153.7. What is the difference between the highest and the second highest Emissions (1000 metric ton of CO2 equivalent) in 2005?
Keep it short and to the point. 1137. What is the difference between the highest and the second highest Emissions (1000 metric ton of CO2 equivalent) of 2008?
Offer a very short reply. 1158.4. What is the difference between the highest and the lowest Emissions (1000 metric ton of CO2 equivalent) of 1990?
Offer a very short reply. 3631.8. What is the difference between the highest and the lowest Emissions (1000 metric ton of CO2 equivalent) in 2000?
Make the answer very short. 1742.4. What is the difference between the highest and the lowest Emissions (1000 metric ton of CO2 equivalent) of 2005?
Your response must be concise. 1831.7. What is the difference between the highest and the lowest Emissions (1000 metric ton of CO2 equivalent) in 2008?
Your answer should be very brief. 1877.7. 